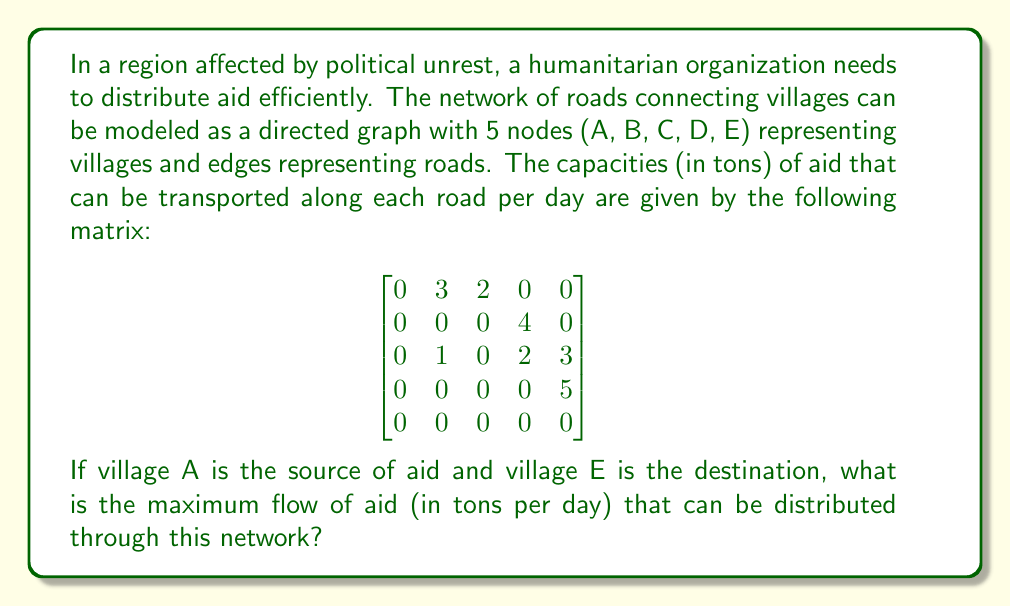Solve this math problem. To solve this problem, we'll use the Ford-Fulkerson algorithm to find the maximum flow in the network. Let's follow these steps:

1) First, we identify all possible paths from A (source) to E (sink):
   Path 1: A -> B -> D -> E
   Path 2: A -> C -> D -> E
   Path 3: A -> C -> E

2) We'll iterate through these paths, augmenting the flow each time:

   Iteration 1 (Path 1):
   A -> B -> D -> E
   Min capacity = min(3, 4, 5) = 3
   Flow = 3

   Iteration 2 (Path 2):
   A -> C -> D -> E
   Min capacity = min(2, 2, 5-3) = 2
   Flow = 3 + 2 = 5

   Iteration 3 (Path 3):
   A -> C -> E
   Min capacity = min(2-2, 3) = 0
   No additional flow

3) After these iterations, we can't find any more augmenting paths. Therefore, the maximum flow is 5 tons per day.

This solution ensures that aid reaches the destination E as efficiently as possible, given the constraints of the road network. It represents a crucial optimization for humanitarian aid distribution in a region facing political unrest and potential resource limitations.
Answer: 5 tons per day 